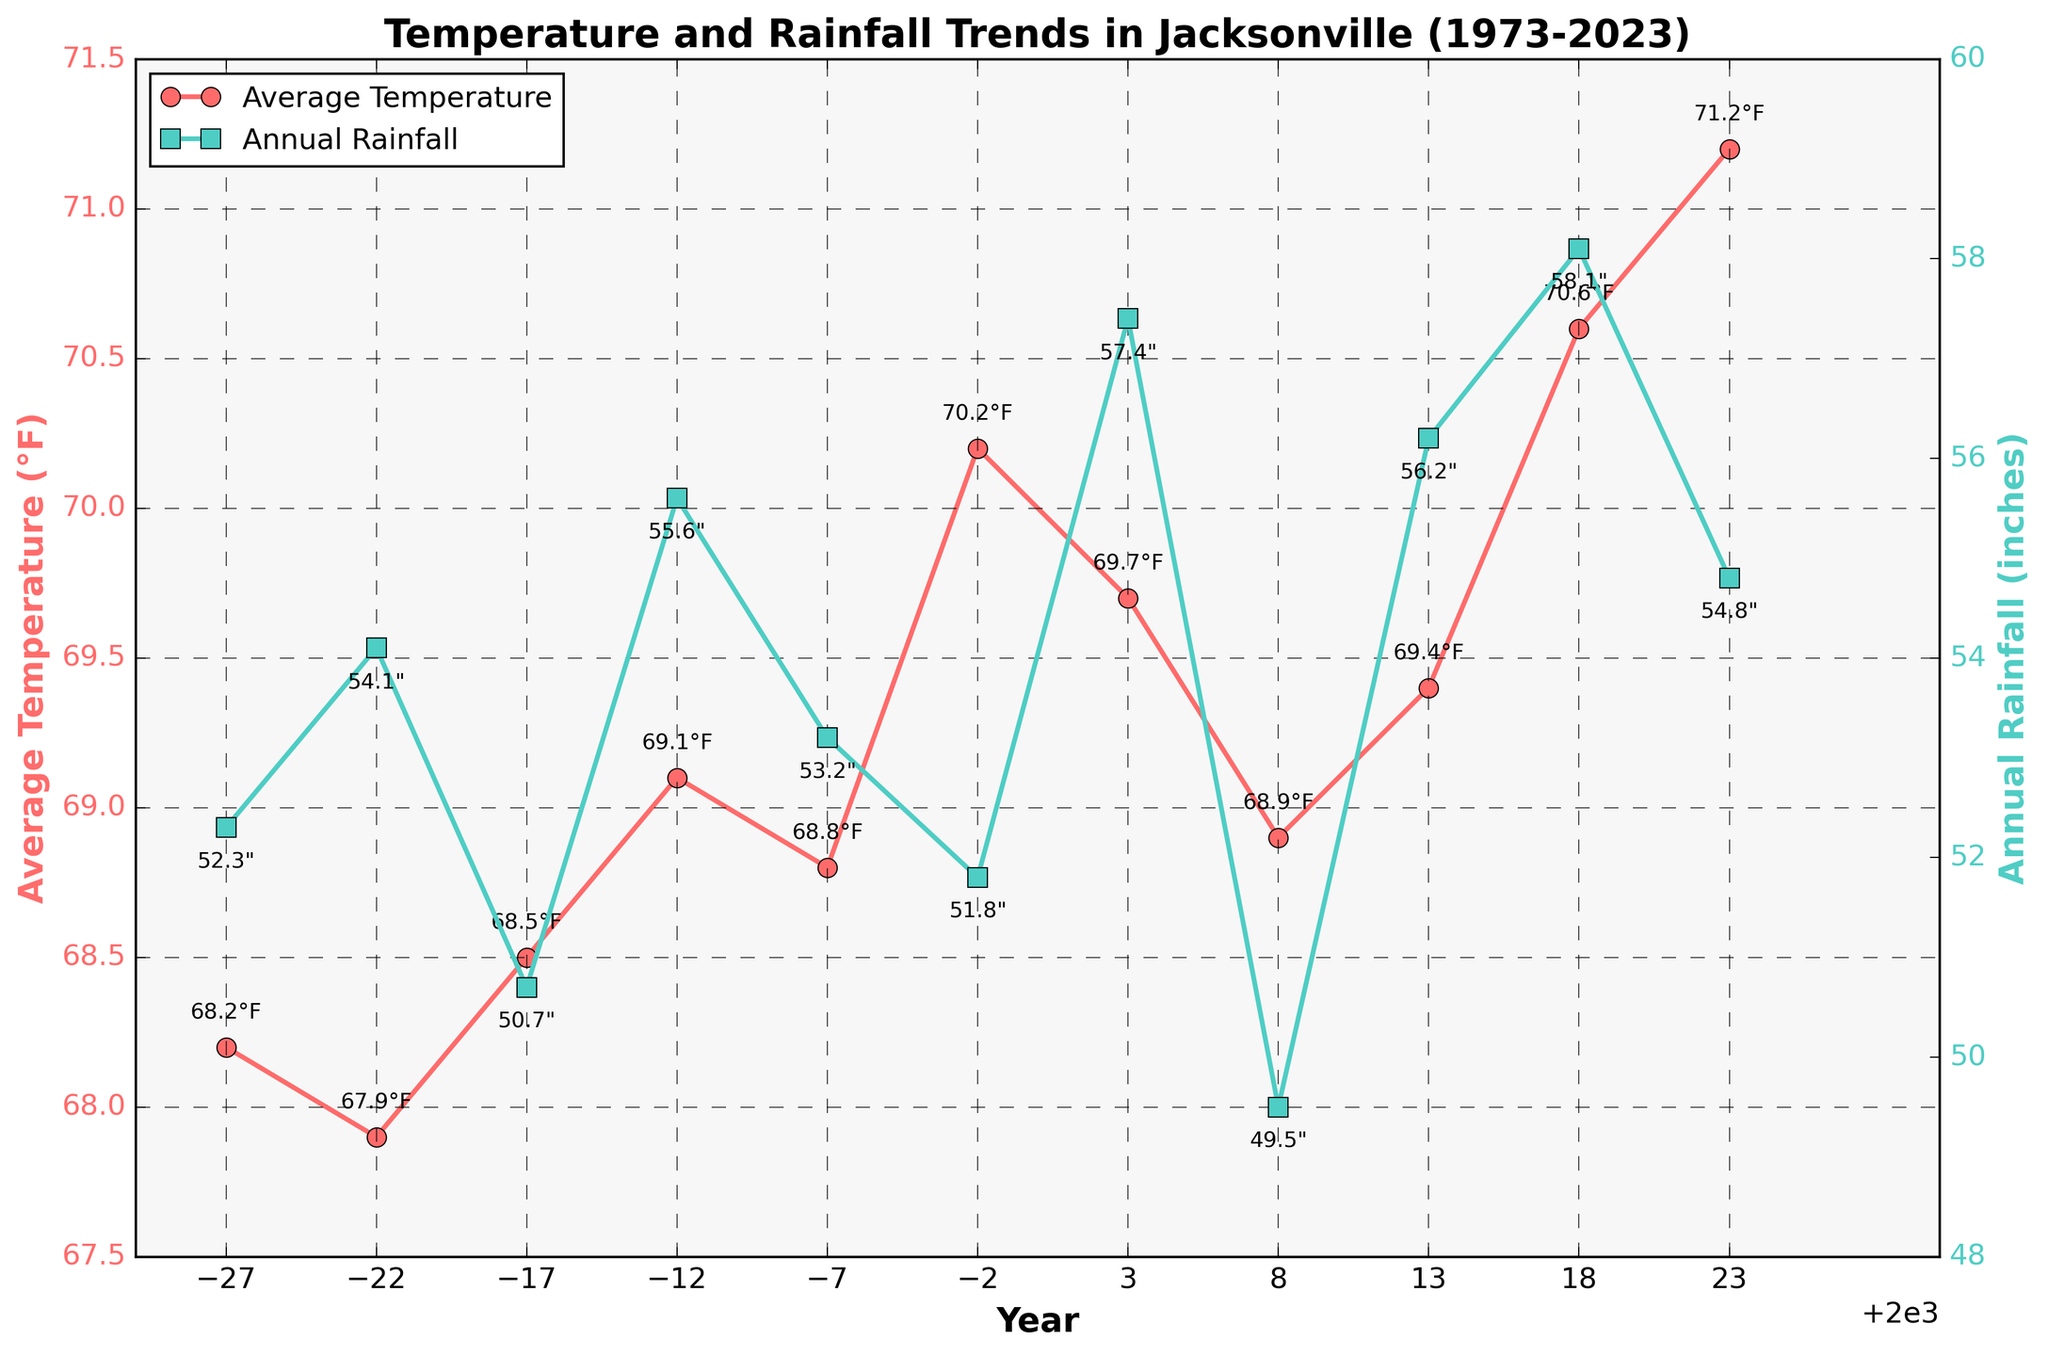What is the trend in average temperature from 1973 to 2023? To identify the trend, observe the line representing average temperature over the years. The line generally shows an upward movement from around 68.2°F in 1973 to 71.2°F in 2023, indicating an increase in average temperature.
Answer: Increasing Which was the year with the highest average temperature, and what was the temperature? Check for the highest point on the temperature line graph. The highest average temperature is in 2023, with a value of 71.2°F.
Answer: 2023, 71.2°F How did the annual rainfall change between 2003 and 2008? Look at the data points for annual rainfall in 2003 and 2008. In 2003, the rainfall was 57.4 inches, and in 2008, it was 49.5 inches, showing a decrease.
Answer: Decreased On what year did the average temperature cross the 70°F mark? Find the year when the average temperature line first crosses the 70°F mark. This first occurs in 1998, when the temperature is 70.2°F.
Answer: 1998 Which year had a higher annual rainfall: 1988 or 2023? Compare the data points for annual rainfall in 1988 and 2023. In 1988, the rainfall was 55.6 inches, and in 2023, it was 54.8 inches.
Answer: 1988 What is the average annual rainfall over the 50 years? To compute the average annual rainfall, sum the annual rainfall values and divide by the number of years (10). \( (52.3 + 54.1 + 50.7 + 55.6 + 53.2 + 51.8 + 57.4 + 49.5 + 56.2 + 58.1 + 54.8) / 11 \approx 53.9 \)
Answer: 53.9 inches Between which two consecutive years did the average temperature increase the most? Check the differences in average temperature between consecutive years. The largest increase is between 2018 (70.6°F) and 2023 (71.2°F), with a rise of 0.6°F.
Answer: 2018 and 2023 How does the temperature trend compare with the rainfall trend over the 50 years? Observe both the temperature and rainfall trends. The temperature generally shows an increasing trend, while the rainfall shows fluctuations with no clear upward or downward trend.
Answer: Temperature is increasing; rainfall fluctuates What's the difference in average temperature between the years 1973 and 2023? Subtract the average temperature of 1973 (68.2°F) from that of 2023 (71.2°F). \( 71.2 - 68.2 = 3 \)
Answer: 3°F What color represents the annual rainfall visualization in the chart? Examine the chart and identify the color used for the annual rainfall line. The line is shown in green.
Answer: Green 